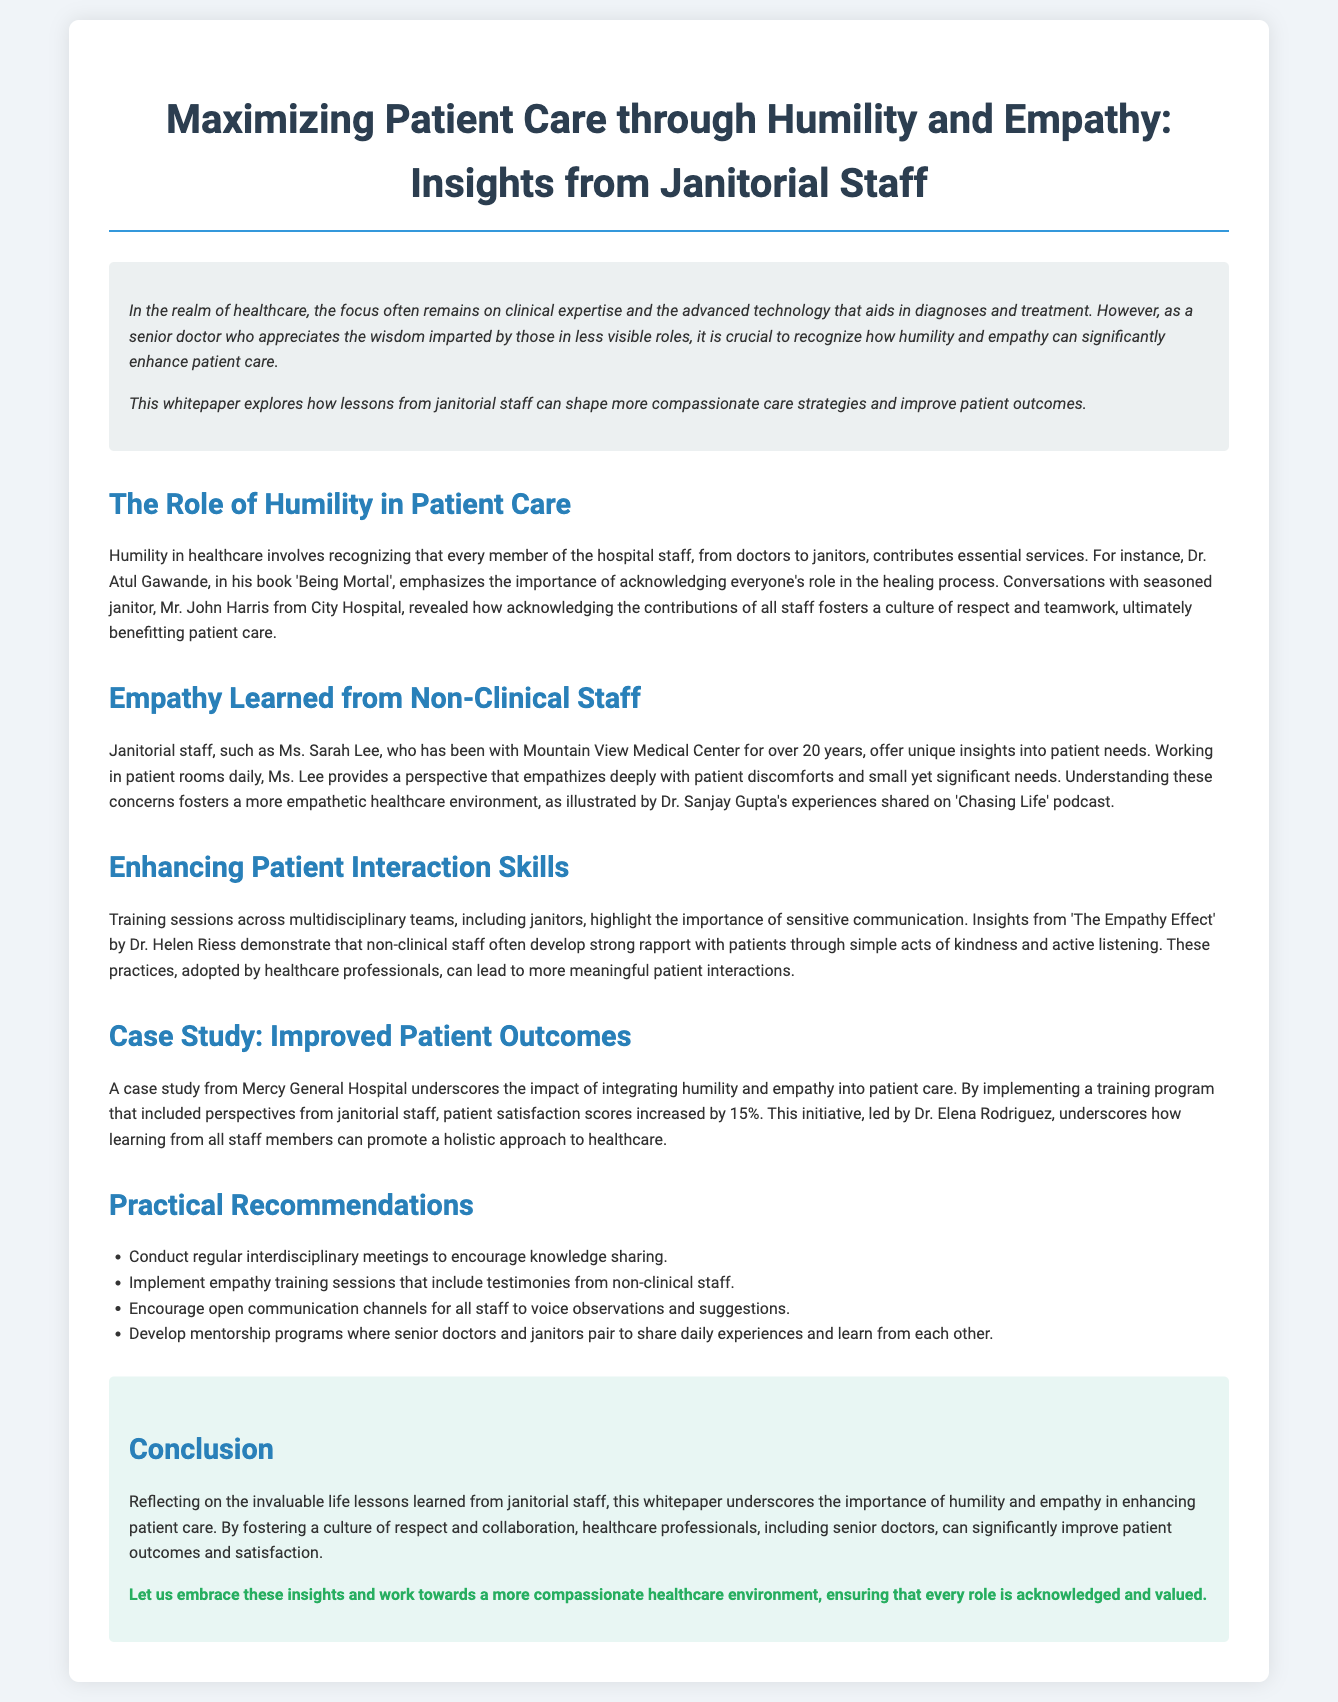What is the title of the whitepaper? The title can be found at the top of the document and provides the central theme of the paper.
Answer: Maximizing Patient Care through Humility and Empathy: Insights from Janitorial Staff Who is the seasoned janitor mentioned in the document? The document references a specific janitor whose insights are highlighted, showing the importance of his perspective.
Answer: Mr. John Harris What hospital is referenced in the case study? The case study outlines the impacts of a specific initiative in a particular hospital, illustrating the significance of humility and empathy.
Answer: Mercy General Hospital By what percentage did patient satisfaction scores increase after the training program? The document states a specific numeric outcome from the implementation of a training program, showing its effectiveness.
Answer: 15% What is recommended to encourage knowledge sharing among staff? The document suggests a specific type of meeting to foster communication and collaboration.
Answer: Regular interdisciplinary meetings What book does Dr. Atul Gawande write about the importance of acknowledging staff roles? The document mentions a specific publication by a notable doctor emphasizing teamwork and humility in healthcare.
Answer: Being Mortal What aspect of patient interaction do janitorial staff contribute to significantly? The insights from janitorial staff reveal an important element of patient care that supports the overall healthcare experience.
Answer: Empathy Who led the training program discussed in the case study? The document identifies a specific individual who was responsible for implementing the discussed initiative, demonstrating leadership in the project.
Answer: Dr. Elena Rodriguez What vital concept does the whitepaper emphasize for improving patient outcomes? The overarching theme of the document is focused on a specific approach that enhances the patient care experience.
Answer: Humility and empathy 